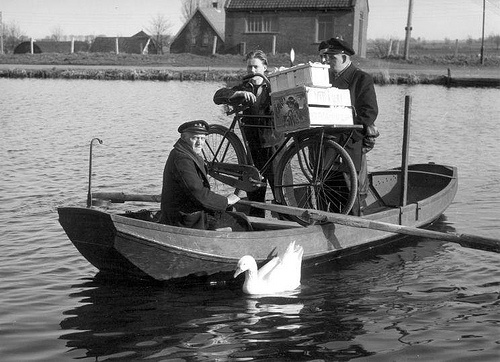Describe the objects in this image and their specific colors. I can see boat in lightgray, black, darkgray, and gray tones, bicycle in lightgray, black, gray, and darkgray tones, people in lightgray, black, gray, and darkgray tones, people in lightgray, black, gray, and darkgray tones, and people in lightgray, black, gray, and darkgray tones in this image. 